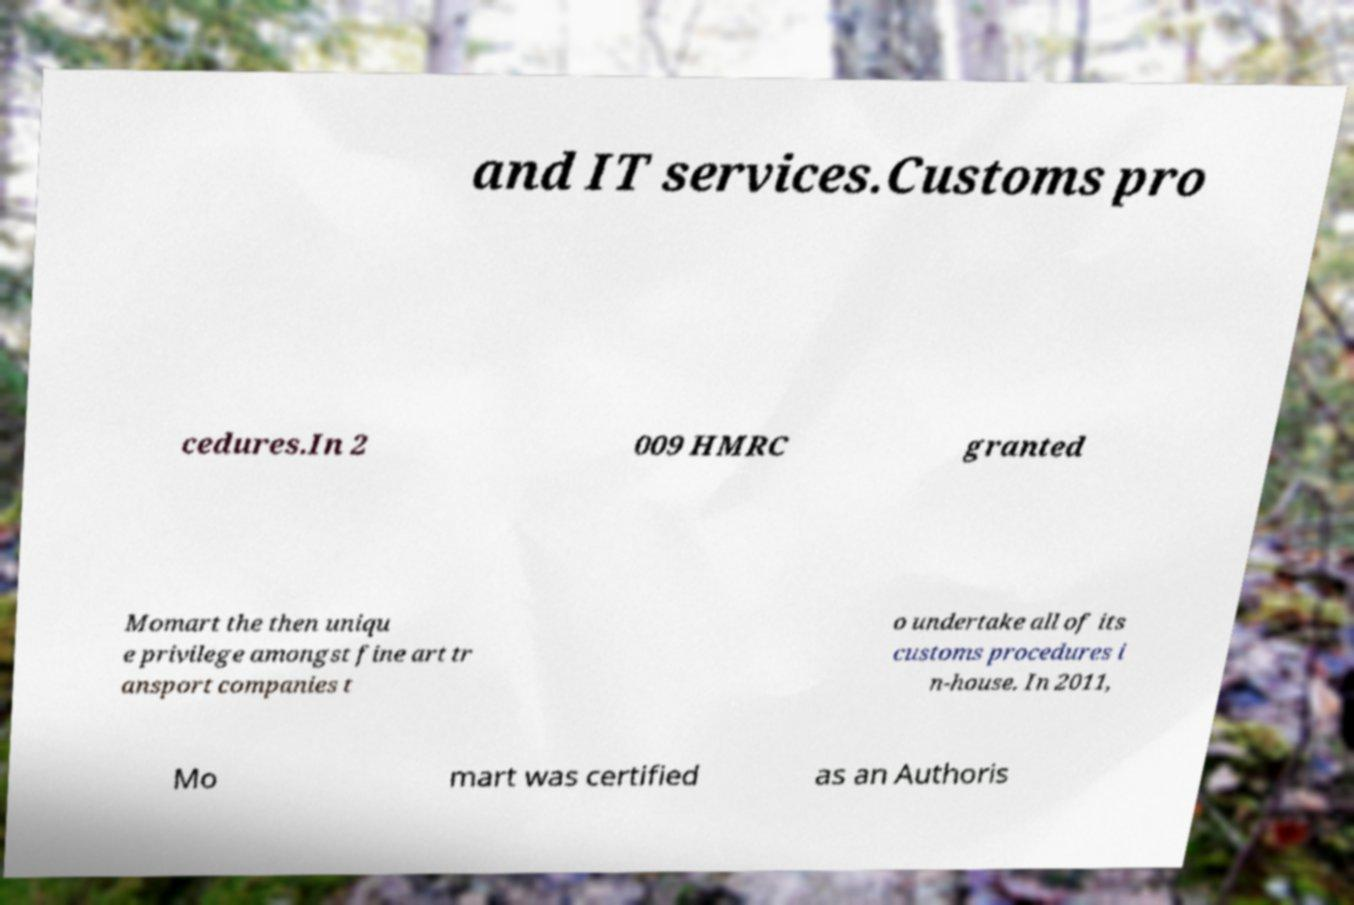Please read and relay the text visible in this image. What does it say? and IT services.Customs pro cedures.In 2 009 HMRC granted Momart the then uniqu e privilege amongst fine art tr ansport companies t o undertake all of its customs procedures i n-house. In 2011, Mo mart was certified as an Authoris 